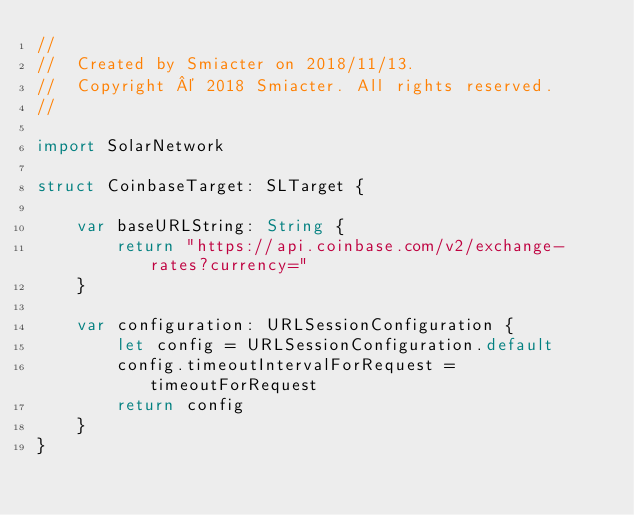Convert code to text. <code><loc_0><loc_0><loc_500><loc_500><_Swift_>//
//  Created by Smiacter on 2018/11/13.
//  Copyright © 2018 Smiacter. All rights reserved.
//

import SolarNetwork

struct CoinbaseTarget: SLTarget {
    
    var baseURLString: String {
        return "https://api.coinbase.com/v2/exchange-rates?currency="
    }
    
    var configuration: URLSessionConfiguration {
        let config = URLSessionConfiguration.default
        config.timeoutIntervalForRequest = timeoutForRequest
        return config
    }
}
</code> 